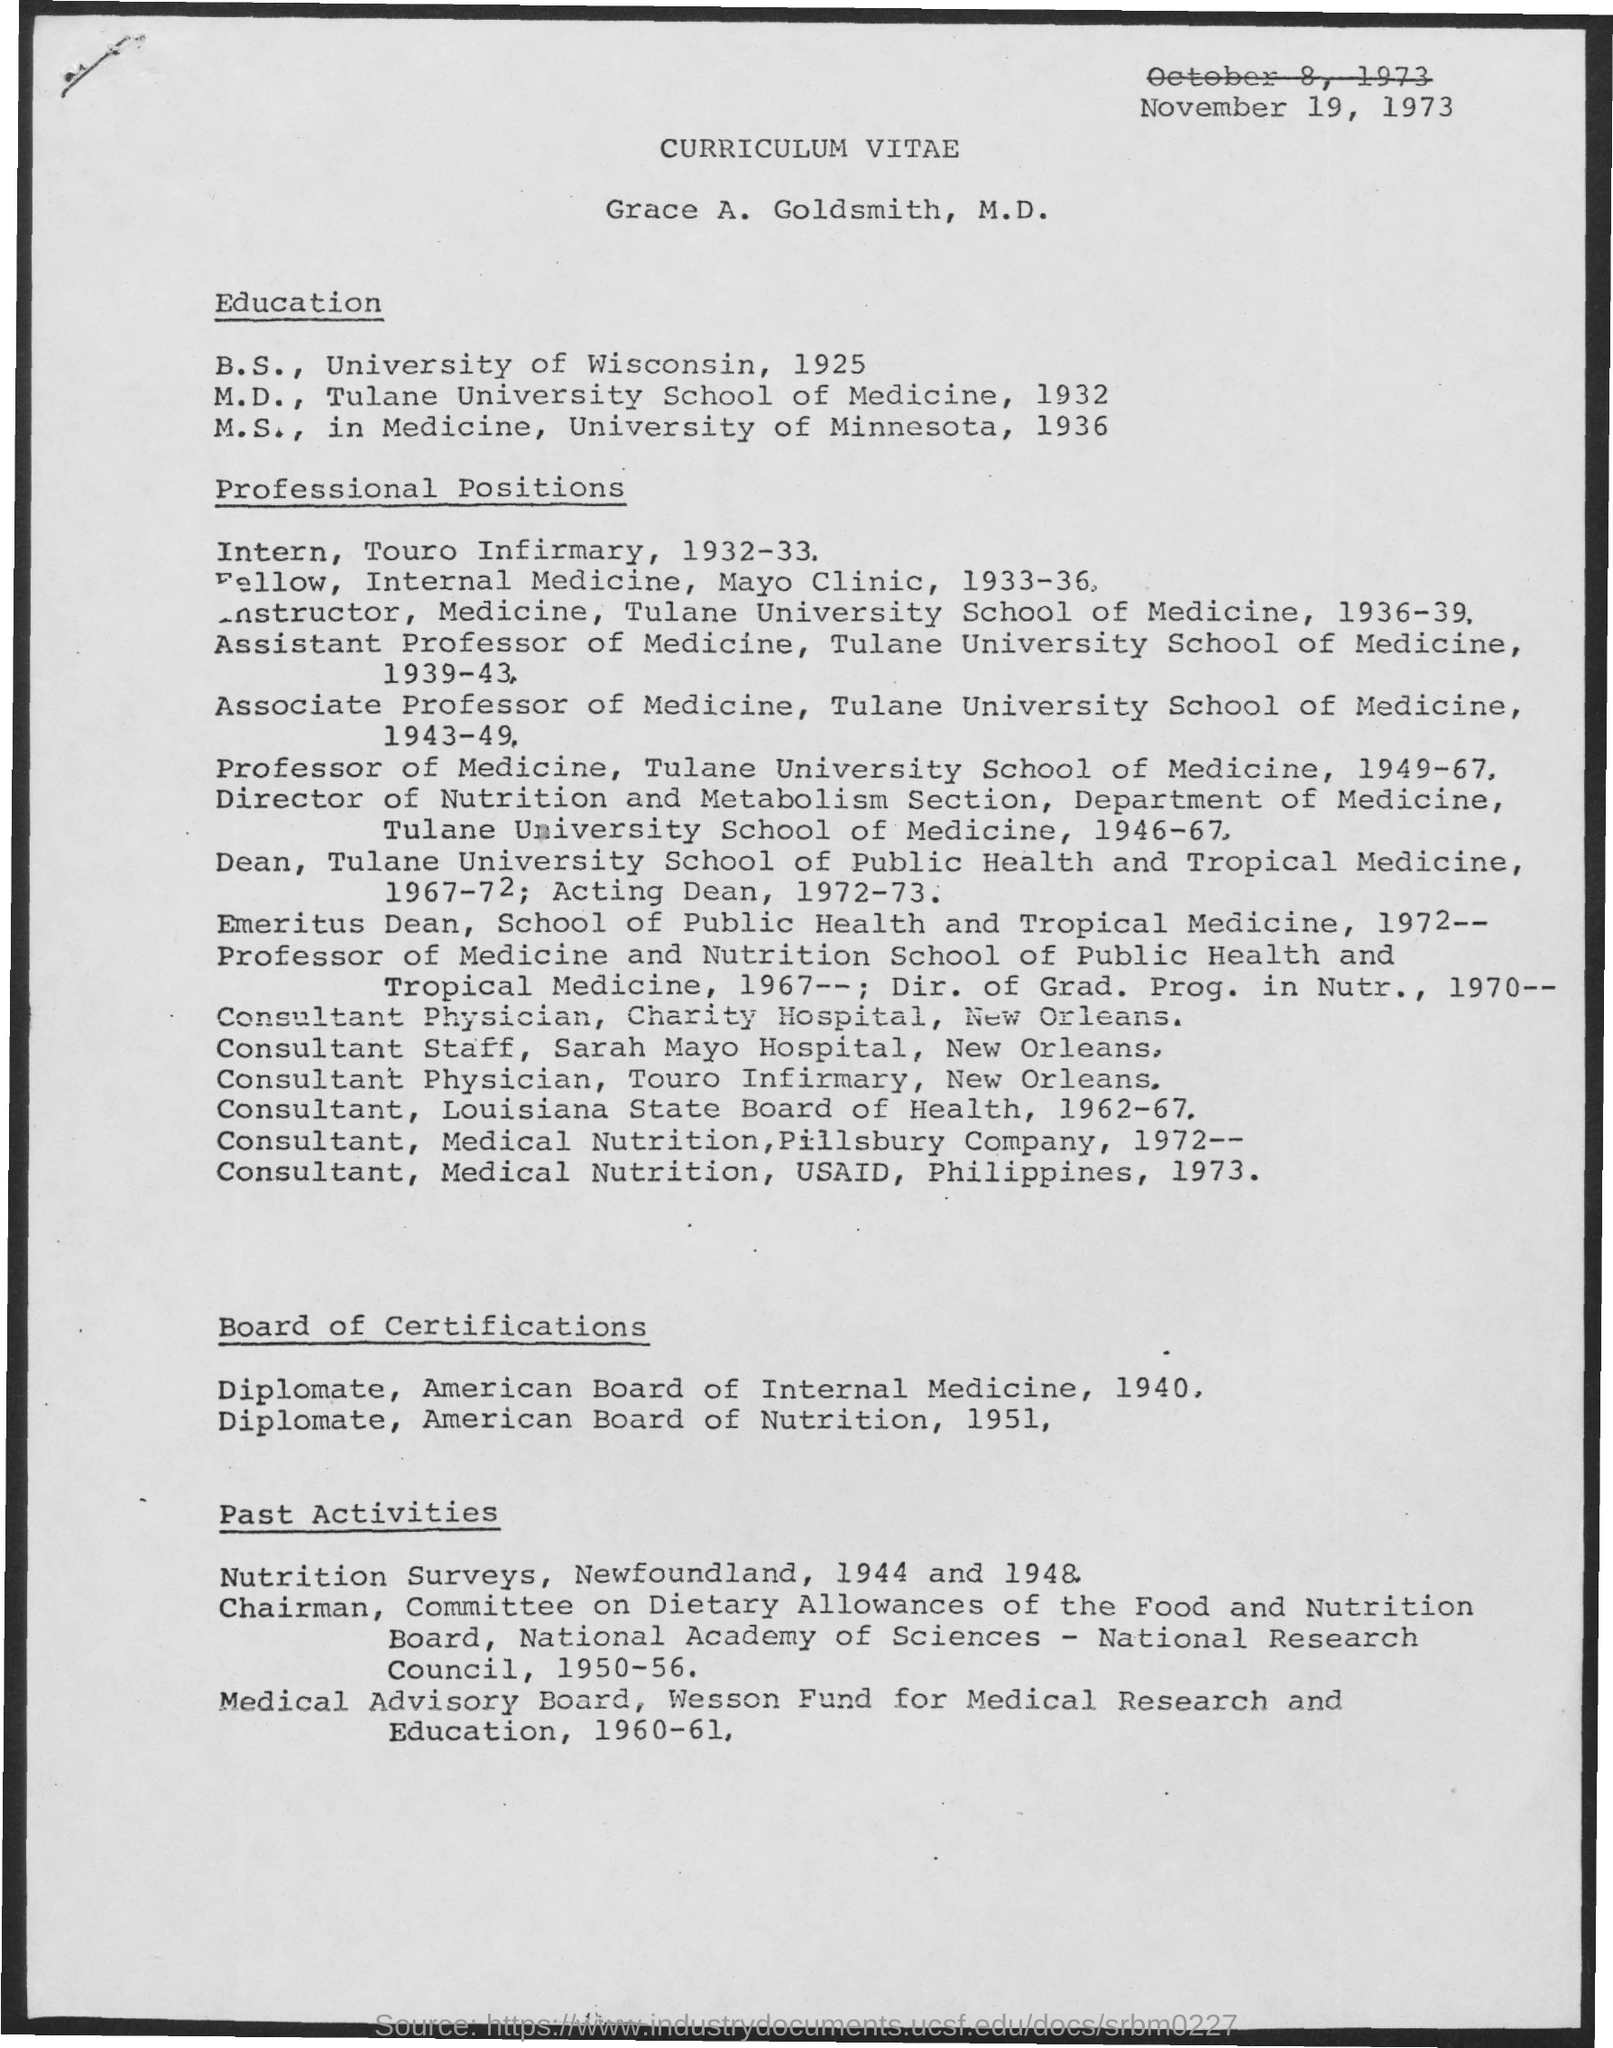Indicate a few pertinent items in this graphic. In 1932, Dr. S. Radhakrishnan completed his M.D. John completed his M.S in the field of Medicine. The individual in question obtained their Master's degree from the University of Minnesota. Around 1925, the speaker completed his Bachelor of Science degree. The date mentioned in the curriculum vitae is November 19, 1973. 